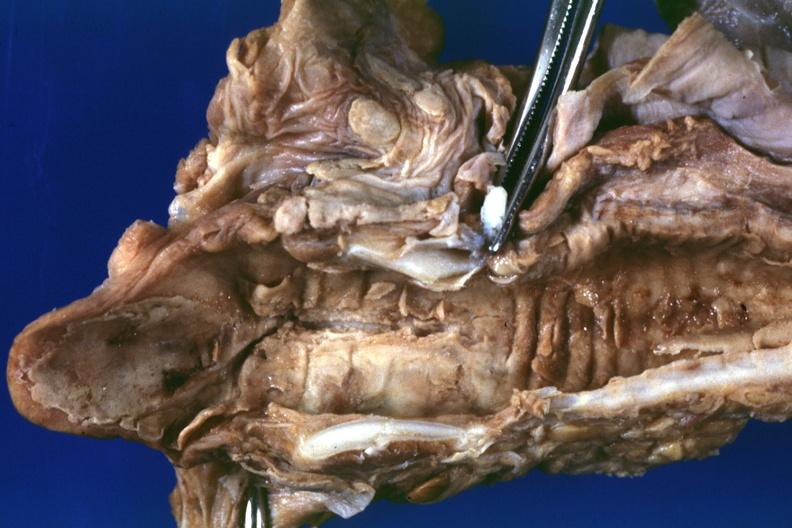what is present?
Answer the question using a single word or phrase. Herpes simplex 